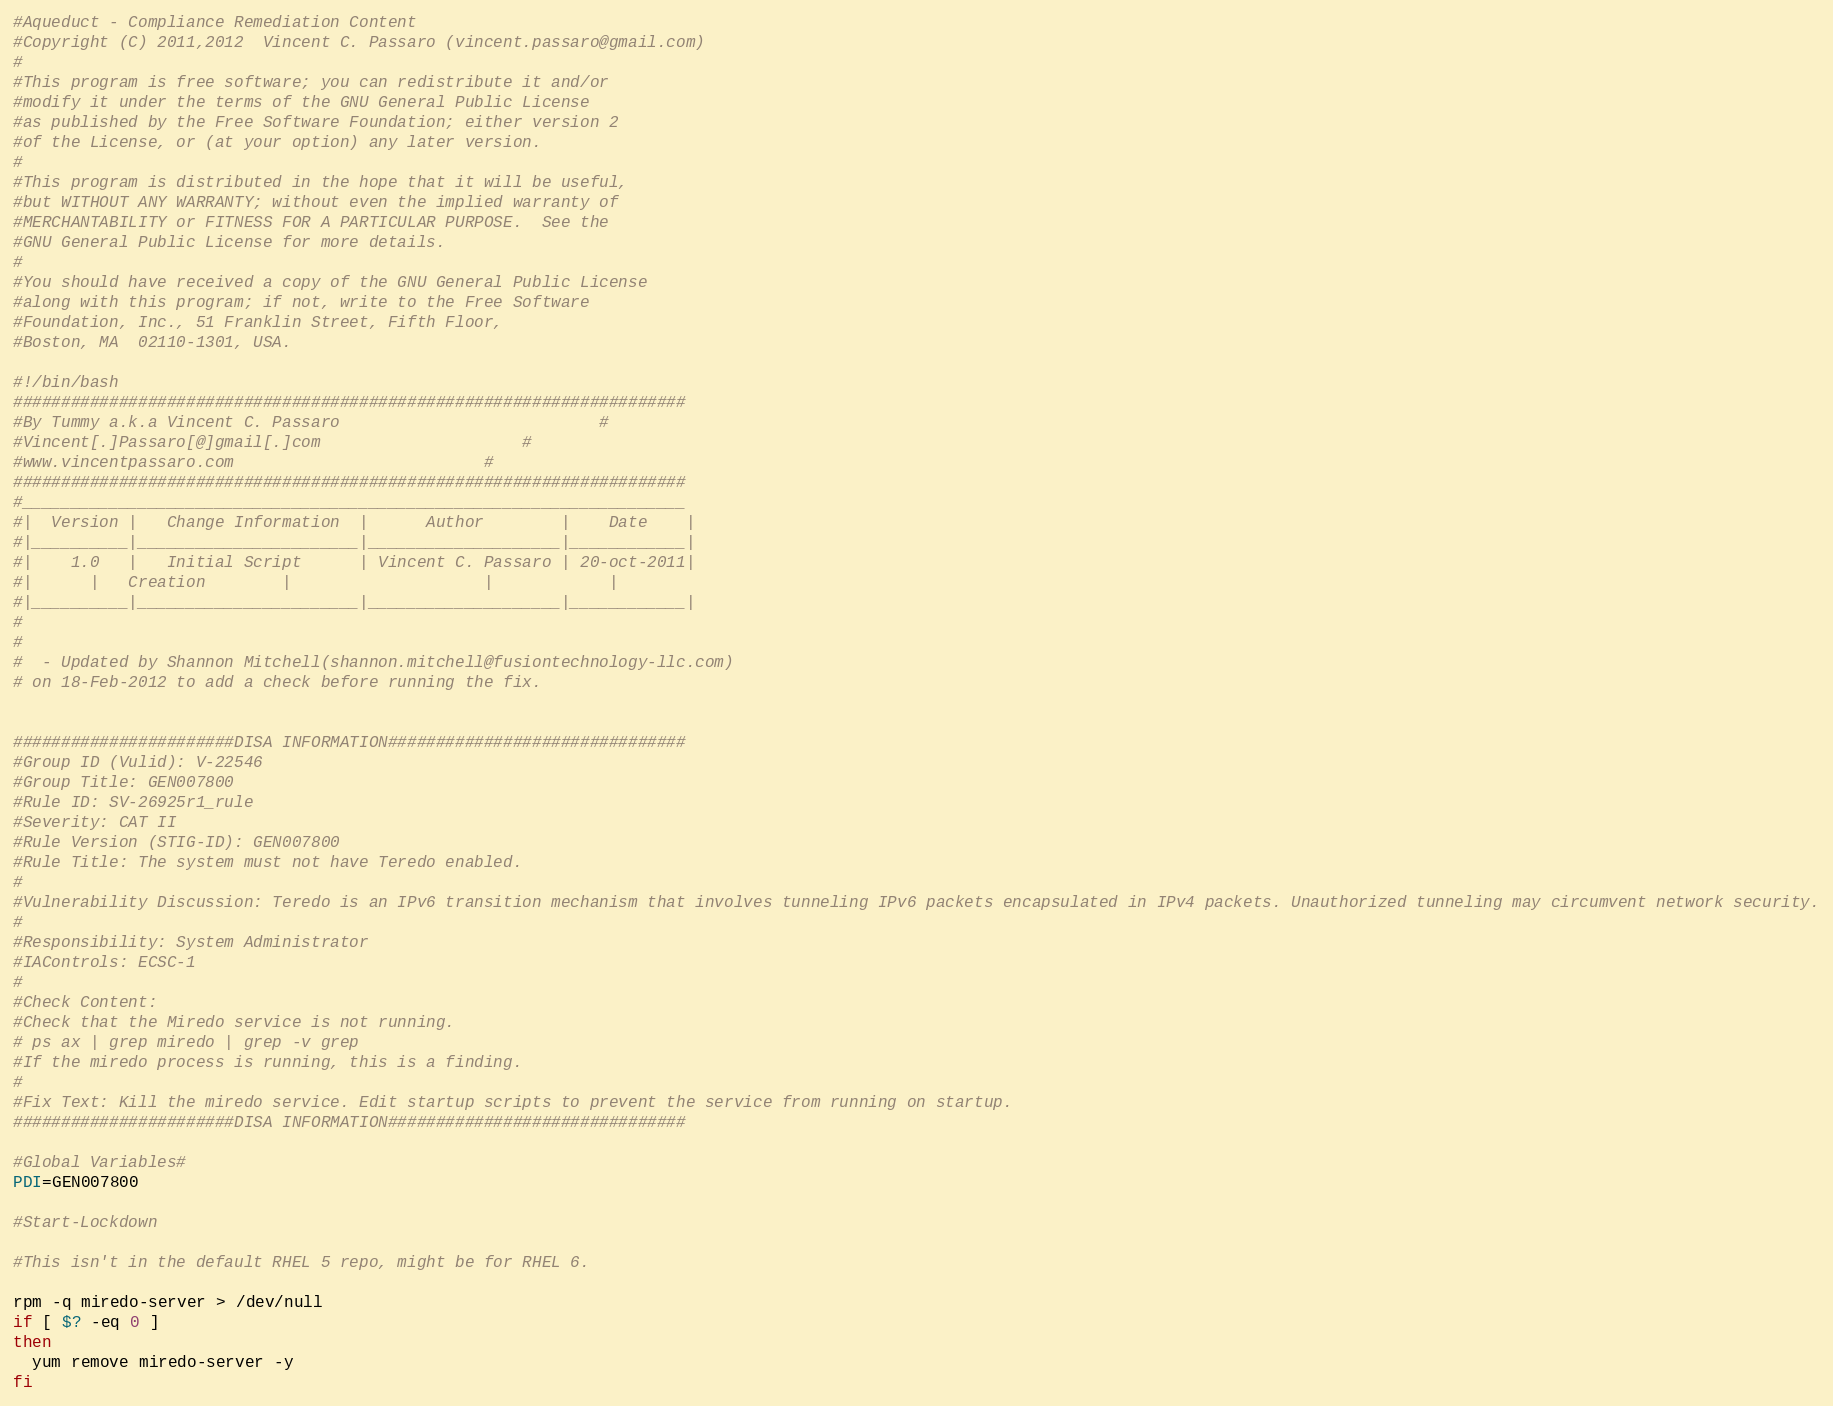Convert code to text. <code><loc_0><loc_0><loc_500><loc_500><_Bash_>#Aqueduct - Compliance Remediation Content
#Copyright (C) 2011,2012  Vincent C. Passaro (vincent.passaro@gmail.com)
#
#This program is free software; you can redistribute it and/or
#modify it under the terms of the GNU General Public License
#as published by the Free Software Foundation; either version 2
#of the License, or (at your option) any later version.
#
#This program is distributed in the hope that it will be useful,
#but WITHOUT ANY WARRANTY; without even the implied warranty of
#MERCHANTABILITY or FITNESS FOR A PARTICULAR PURPOSE.  See the
#GNU General Public License for more details.
#
#You should have received a copy of the GNU General Public License
#along with this program; if not, write to the Free Software
#Foundation, Inc., 51 Franklin Street, Fifth Floor,
#Boston, MA  02110-1301, USA.

#!/bin/bash
######################################################################
#By Tummy a.k.a Vincent C. Passaro		                     #
#Vincent[.]Passaro[@]gmail[.]com				     #
#www.vincentpassaro.com						     #
######################################################################
#_____________________________________________________________________
#|  Version |   Change Information  |      Author        |    Date    |
#|__________|_______________________|____________________|____________|
#|    1.0   |   Initial Script      | Vincent C. Passaro | 20-oct-2011|
#|	    |   Creation	    |                    |            |
#|__________|_______________________|____________________|____________|
#
#
#  - Updated by Shannon Mitchell(shannon.mitchell@fusiontechnology-llc.com)
# on 18-Feb-2012 to add a check before running the fix.


#######################DISA INFORMATION###############################
#Group ID (Vulid): V-22546
#Group Title: GEN007800
#Rule ID: SV-26925r1_rule
#Severity: CAT II
#Rule Version (STIG-ID): GEN007800
#Rule Title: The system must not have Teredo enabled.
#
#Vulnerability Discussion: Teredo is an IPv6 transition mechanism that involves tunneling IPv6 packets encapsulated in IPv4 packets. Unauthorized tunneling may circumvent network security.
#
#Responsibility: System Administrator
#IAControls: ECSC-1
#
#Check Content: 
#Check that the Miredo service is not running.
# ps ax | grep miredo | grep -v grep
#If the miredo process is running, this is a finding.
#
#Fix Text: Kill the miredo service. Edit startup scripts to prevent the service from running on startup.    
#######################DISA INFORMATION###############################

#Global Variables#
PDI=GEN007800

#Start-Lockdown

#This isn't in the default RHEL 5 repo, might be for RHEL 6.

rpm -q miredo-server > /dev/null
if [ $? -eq 0 ]
then
  yum remove miredo-server -y
fi

</code> 